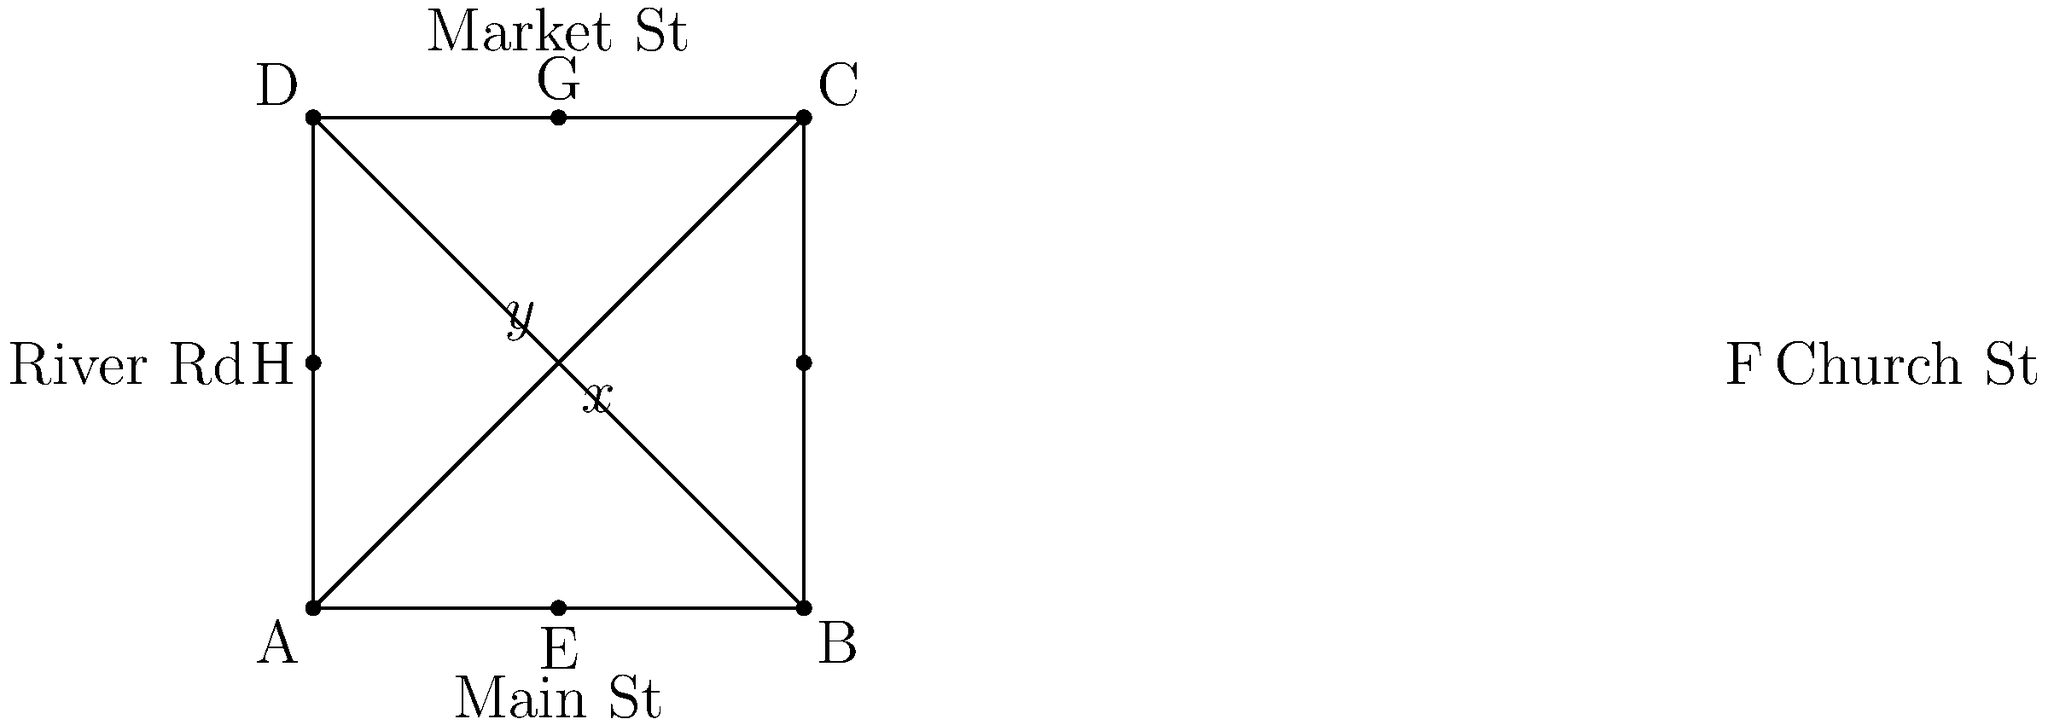In the historic district of Snegiryovka, four main streets intersect as shown in the simplified map above. Main Street and Market Street form a $x°$ angle at their intersection, while Church Street and River Road form a $y°$ angle. If these streets are known to be perpendicular to each other, what is the value of $x + y$? To solve this problem, let's follow these steps:

1) In a four-way intersection where streets are perpendicular, they form four right angles.

2) A right angle is 90°.

3) The sum of angles around a point is 360°.

4) In this case, we have four angles: $x°$, $y°$, and two unnamed angles.

5) We know that:
   $x° + y° + \text{unnamed angle 1} + \text{unnamed angle 2} = 360°$

6) Since the streets are perpendicular, the two unnamed angles must also be right angles (90° each).

7) Substituting this information:
   $x° + y° + 90° + 90° = 360°$

8) Simplifying:
   $x° + y° + 180° = 360°$

9) Subtracting 180° from both sides:
   $x° + y° = 180°$

Therefore, the sum of $x$ and $y$ is 180°.
Answer: 180° 